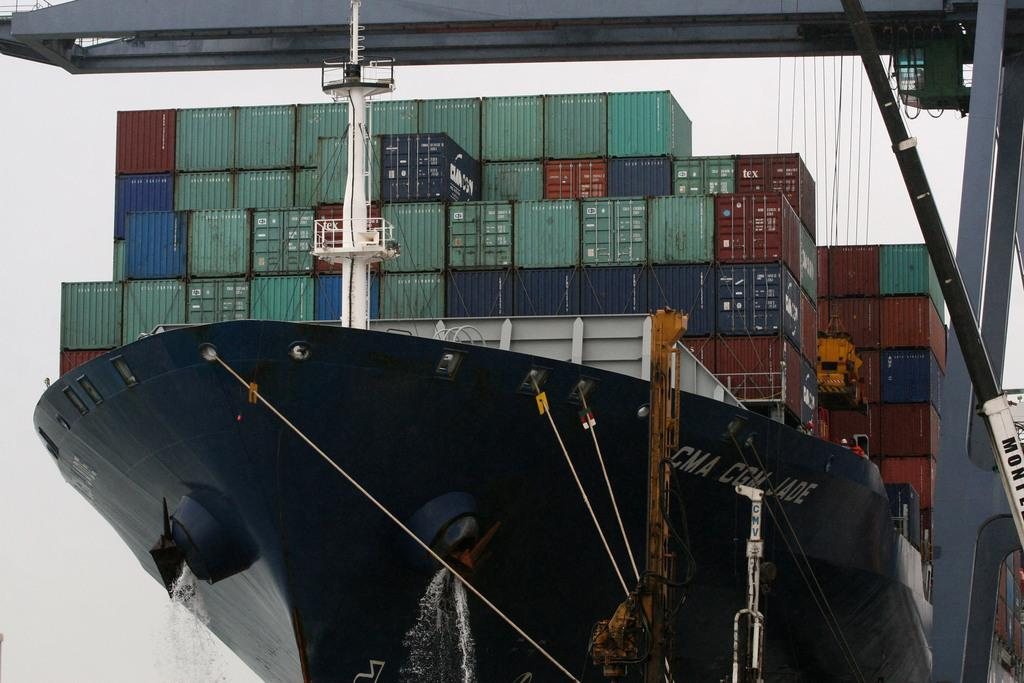What is the main subject of the image? The main subject of the image is a black color ship. What can be found on the ship? The ship contains many containers. What colors are the containers? The containers are in green, blue, brown, and grey colors. What is visible in the background of the image? The sky is visible in the background of the image. How many geese are flying over the ship in the image? There are no geese present in the image; it only features a black color ship with containers and a visible sky in the background. What type of wrench is being used to tighten the containers on the ship? There is no wrench visible in the image, and the containers are not being tightened or manipulated in any way. 